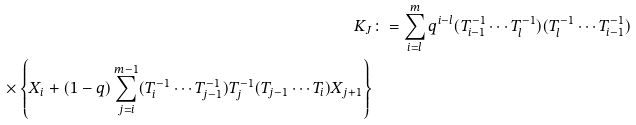Convert formula to latex. <formula><loc_0><loc_0><loc_500><loc_500>K _ { J } & \colon = \sum _ { i = l } ^ { m } q ^ { i - l } ( T _ { i - 1 } ^ { - 1 } \cdots T _ { l } ^ { - 1 } ) ( T _ { l } ^ { - 1 } \cdots T _ { i - 1 } ^ { - 1 } ) \\ \times \left \{ X _ { i } + ( 1 - q ) \sum _ { j = i } ^ { m - 1 } ( T _ { i } ^ { - 1 } \cdots T _ { j - 1 } ^ { - 1 } ) T _ { j } ^ { - 1 } ( T _ { j - 1 } \cdots T _ { i } ) X _ { j + 1 } \right \}</formula> 